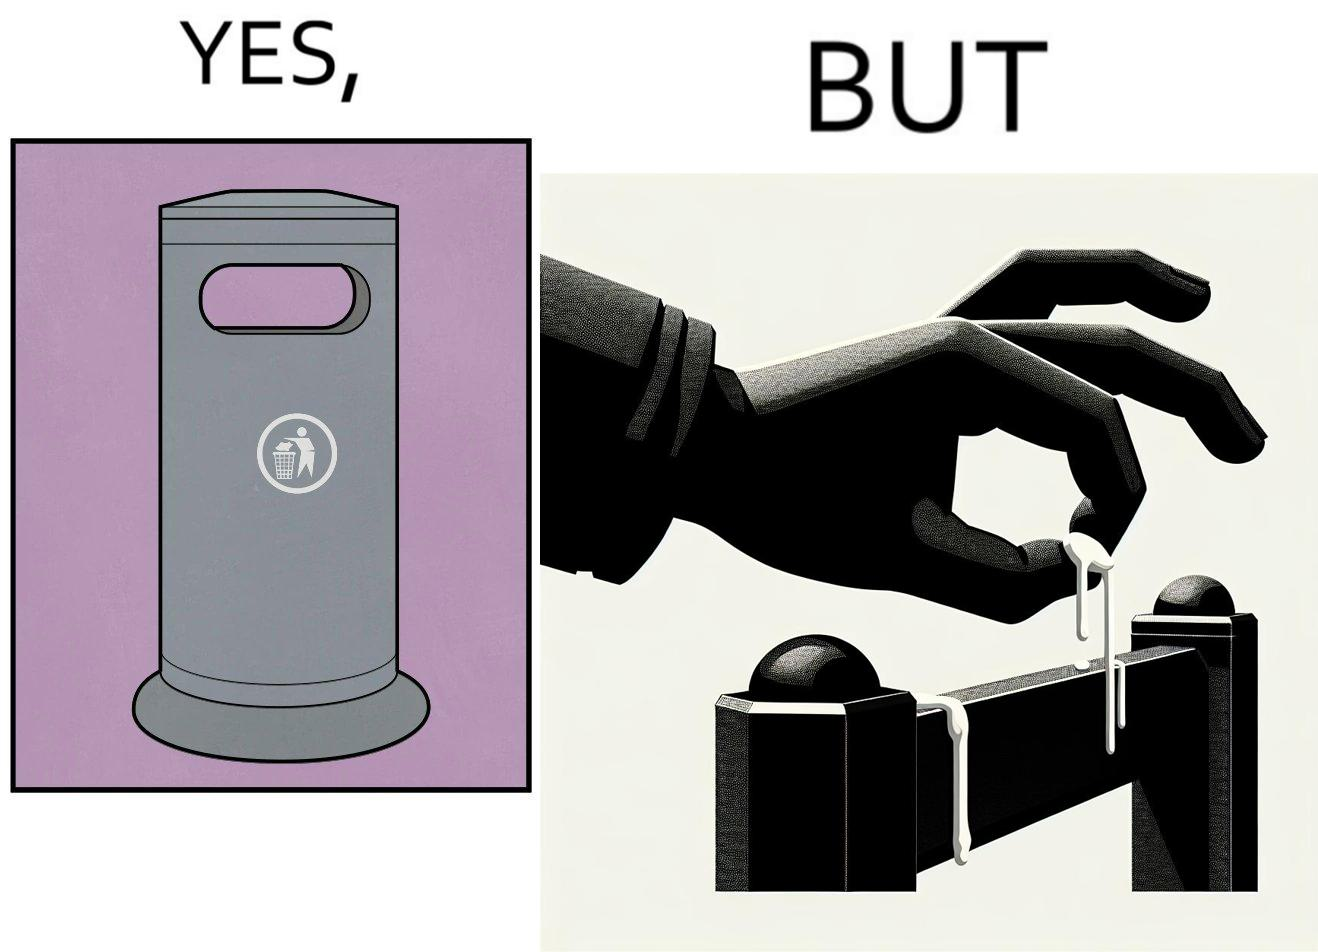What does this image depict? The images are ironic because even though garbage bins are provided for humans to dispose waste, by habit humans still choose to make surroundings dirty by disposing garbage improperly 